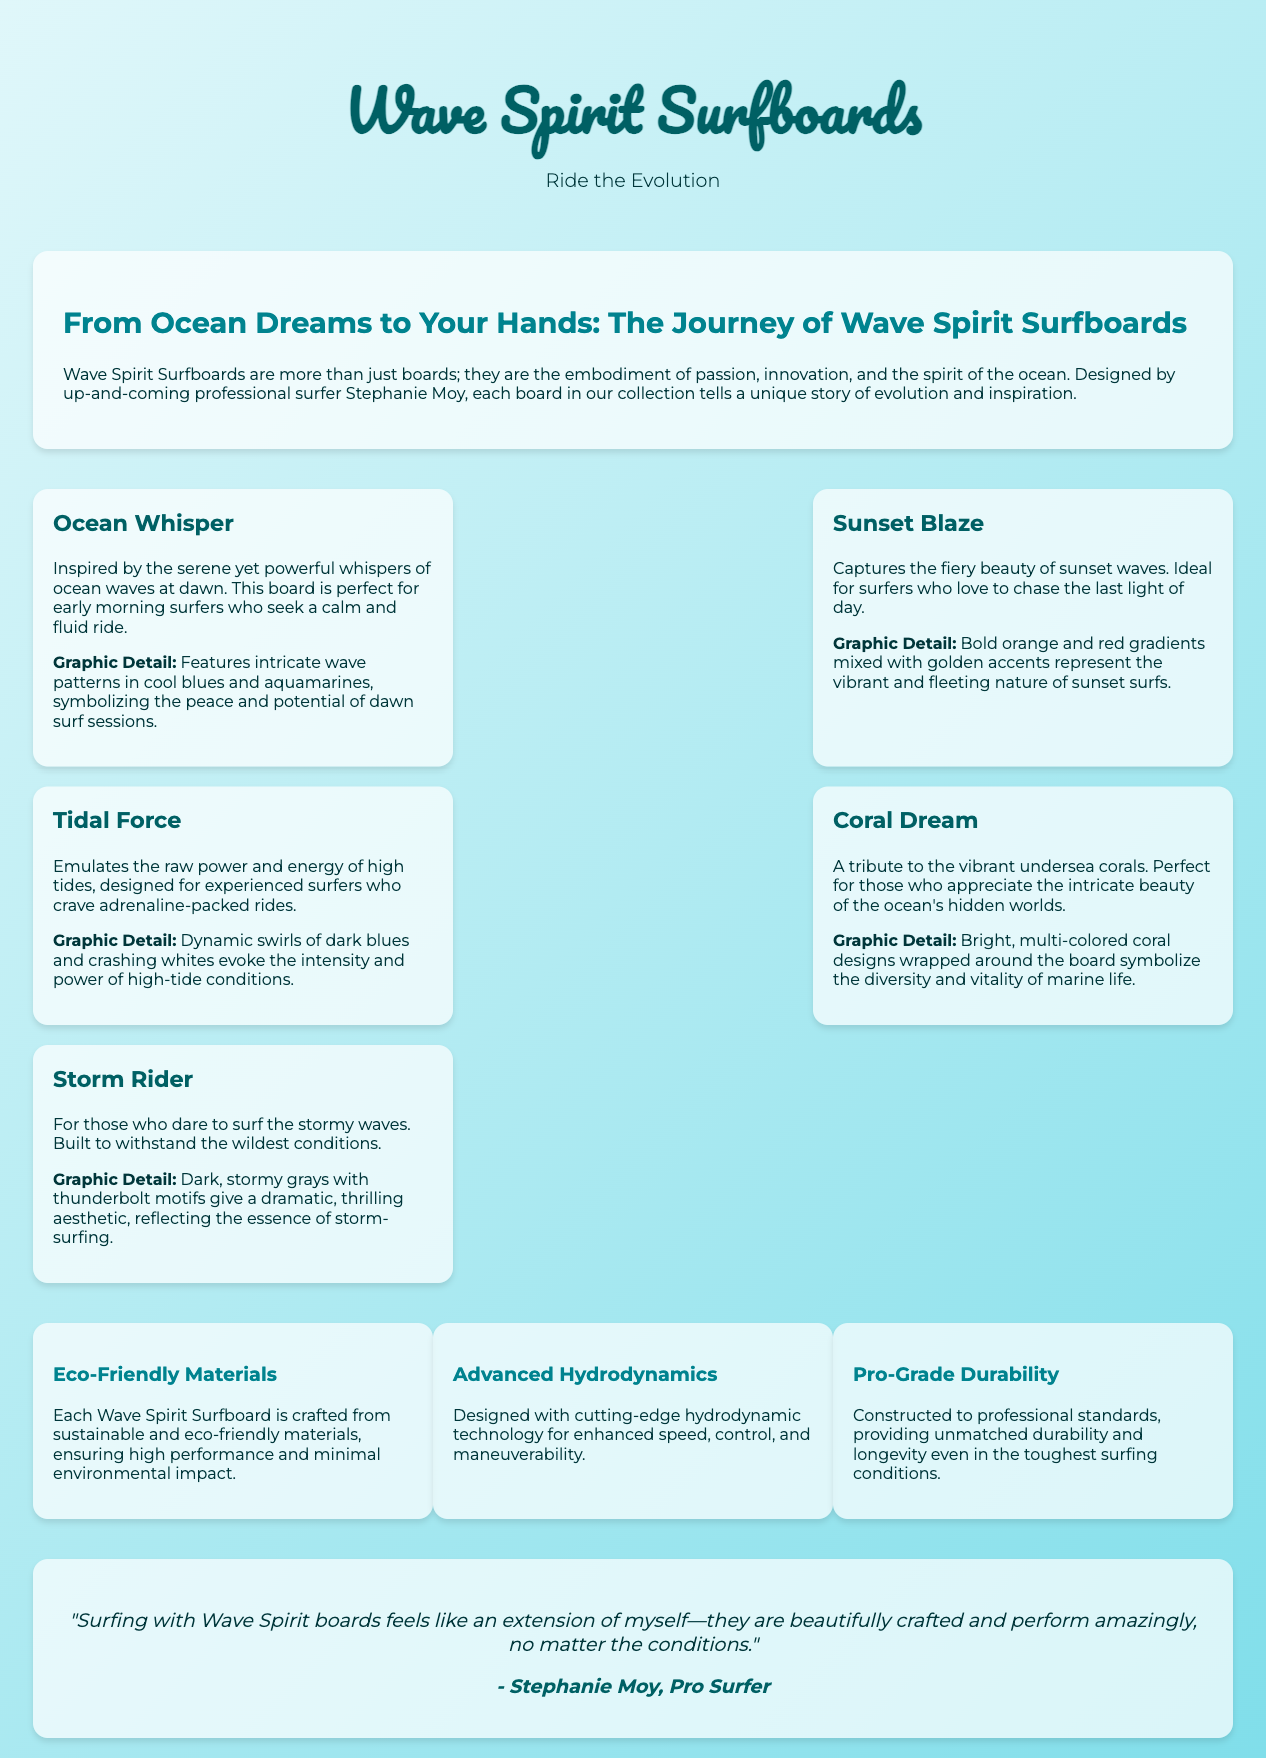what is the name of the surfboard line? The name of the surfboard line is prominently displayed in the title of the document as "Wave Spirit Surfboards."
Answer: Wave Spirit Surfboards who designed the surfboards? The designer of the surfboards is mentioned in the branding story as Stephanie Moy.
Answer: Stephanie Moy what is the tagline of the brand? The tagline is located below the header and promotes the brand's mission.
Answer: Ride the Evolution how many signature models are listed in the document? The document lists five signature models in the section dedicated to them.
Answer: Five which model is inspired by early morning waves? The document specifies that the "Ocean Whisper" model is inspired by early morning waves.
Answer: Ocean Whisper what are the colors used in the "Storm Rider" graphic detail? The graphic detail for "Storm Rider" is described with dark, stormy grays and thunderbolt motifs.
Answer: Dark grays what type of materials are used in the surfboards? The eco-friendly nature and material usage are highlighted in the features section.
Answer: Eco-Friendly Materials which model features coral designs? The "Coral Dream" model is noted for featuring vibrant coral designs on the board.
Answer: Coral Dream what aspect of the surfboards ensures minimal environmental impact? The aspect ensuring minimal environmental impact is noted as being crafted from sustainable materials.
Answer: Sustainable materials 